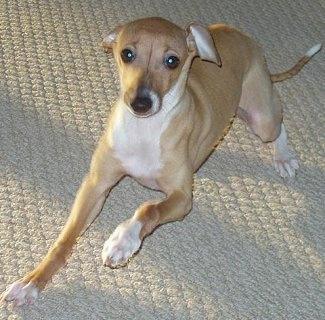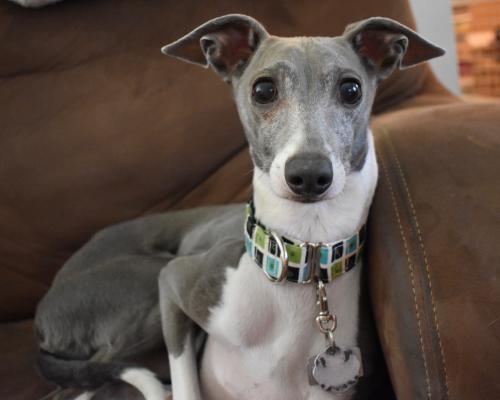The first image is the image on the left, the second image is the image on the right. Assess this claim about the two images: "In one image, a gray and white dog with ears that point to the side is wearing a collar with a dangling charm.". Correct or not? Answer yes or no. Yes. The first image is the image on the left, the second image is the image on the right. Considering the images on both sides, is "An image shows a gray and white hound wearing a collar with a charm attached." valid? Answer yes or no. Yes. 